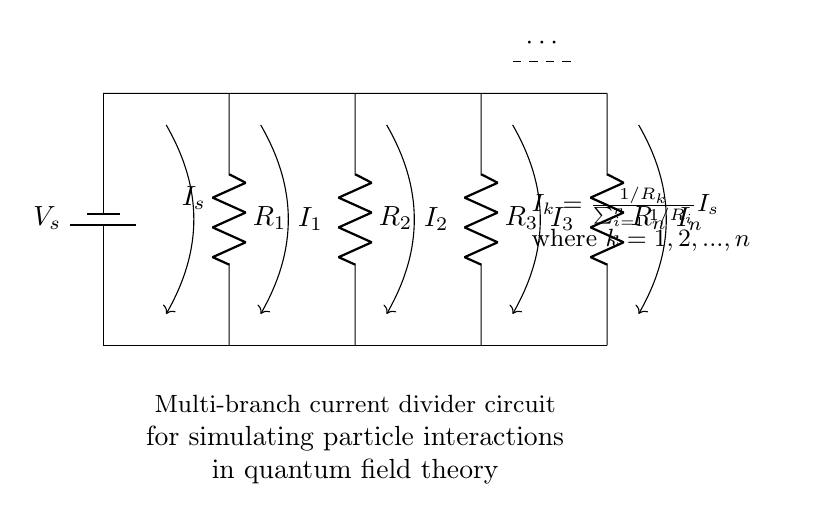What is the source voltage in this circuit? The source voltage is labeled as \( V_s \) in the diagram, indicating the potential difference provided by the battery.
Answer: V_s What type of circuit configuration is represented here? This is a multi-branch parallel circuit configuration, where the current is divided among multiple resistors.
Answer: Parallel How many resistors are in the circuit? There are \( n \) resistors shown, with the circuit notation indicating a total of \( n \) branches connected in parallel.
Answer: n What is the relationship between the branch currents and the source current? The current through each branch resistor is given by the formula \( I_k = \frac{1/R_k}{\sum_{i=1}^n 1/R_i} I_s \), indicating how the total current \( I_s \) divides among the branches based on their resistance values.
Answer: Proportional to \( 1/R_k \) If one resistor's value is decreased, what generally happens to the current through that branch? When a resistor's value decreases, that branch's current \( I_k \) increases according to the current divider formula, as lower resistance allows more current to flow through the branch.
Answer: Increases Which parameter determines the distribution of current among the branches? The resistance values of each branch \( R_k \), as they dictate how the total current \( I_s \) is divided inversely to the resistance.
Answer: Resistances What will happen to the total current drawn from the source if the number of resistors is increased, assuming all resistances are equal? If the number of resistors increases, the total current drawn from the source will increase as the total equivalent resistance decreases, allowing more current to flow due to lower resistance in parallel.
Answer: Increases 